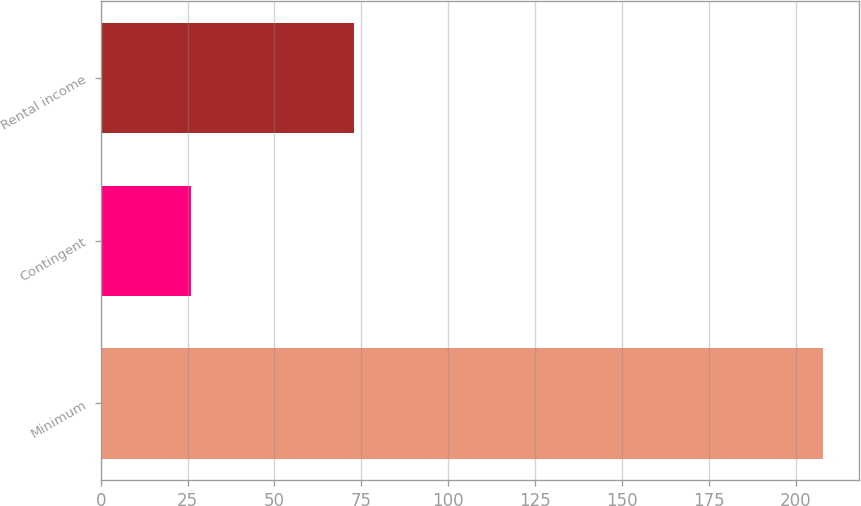Convert chart to OTSL. <chart><loc_0><loc_0><loc_500><loc_500><bar_chart><fcel>Minimum<fcel>Contingent<fcel>Rental income<nl><fcel>208<fcel>26<fcel>73<nl></chart> 